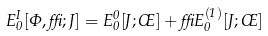<formula> <loc_0><loc_0><loc_500><loc_500>E _ { 0 } ^ { I } [ \Phi , \delta ; J ] = E _ { 0 } ^ { 0 } [ J ; \phi ] + \delta E _ { 0 } ^ { ( 1 ) } [ J ; \phi ]</formula> 